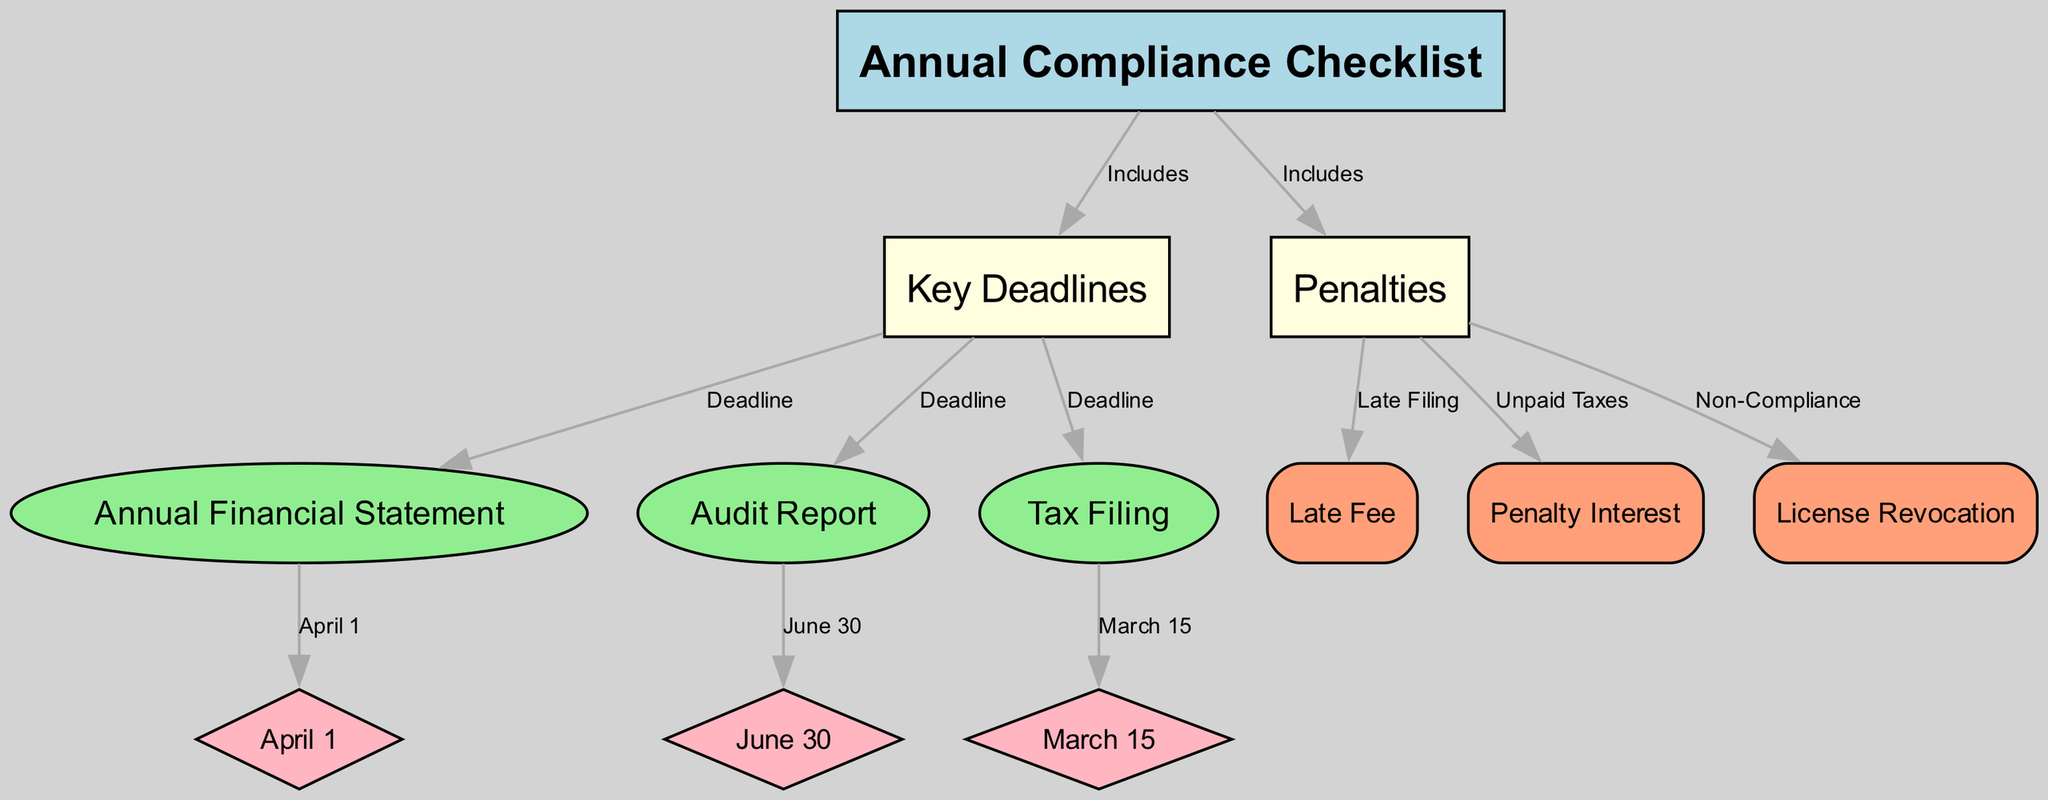What is the main title of the diagram? The diagram is titled "Annual Compliance Checklist," as indicated by the top node in the structure.
Answer: Annual Compliance Checklist How many key deadlines are included in the diagram? There are three key deadlines shown: April 1, June 30, and March 15, which are connected to their respective compliance tasks.
Answer: 3 What is the deadline for the Annual Financial Statement? The deadline for the Annual Financial Statement is shown as April 1, connected by an edge labeled "April 1".
Answer: April 1 What is the penalty for late filing? The penalty for late filing is indicated as a "Late Fee," which is connected from the Penalties node to the Penalty label node.
Answer: Late Fee Which task must be completed by March 15? The task that must be completed by March 15 is the "Tax Filing," which is directly connected to this deadline node in the diagram.
Answer: Tax Filing If a company does not comply, what penalty might it face? According to the diagram, a company faces "License Revocation" as a penalty for non-compliance, making this a severe consequence listed.
Answer: License Revocation How many nodes represent compliance tasks in the diagram? There are three nodes that represent compliance tasks: Annual Financial Statement, Audit Report, and Tax Filing, which are linked to the compliance checklist.
Answer: 3 What color represents the Key Deadlines node? The Key Deadlines node is highlighted in light yellow, differentiating it from other types of nodes in the diagram.
Answer: Light Yellow What happens if taxes are unpaid? If taxes are unpaid, the consequence is "Penalty Interest," which is documented as a penalty in the diagram under the penalties section.
Answer: Penalty Interest 